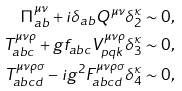<formula> <loc_0><loc_0><loc_500><loc_500>\Pi _ { a b } ^ { \mu \nu } + i \delta _ { a b } Q ^ { \mu \nu } \delta _ { 2 } ^ { \kappa } & \sim 0 , \\ T _ { a b c } ^ { \mu \nu \rho } + g f _ { a b c } V _ { p q k } ^ { \mu \nu \rho } \delta _ { 3 } ^ { \kappa } & \sim 0 , \\ T _ { a b c d } ^ { \mu \nu \rho \sigma } - i g ^ { 2 } F _ { a b c d } ^ { \mu \nu \rho \sigma } \delta _ { 4 } ^ { \kappa } & \sim 0 ,</formula> 